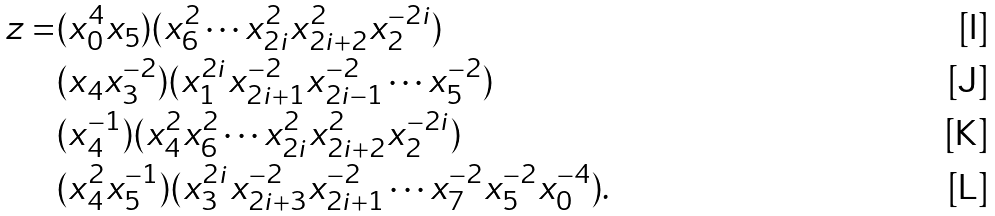<formula> <loc_0><loc_0><loc_500><loc_500>z = & ( x _ { 0 } ^ { 4 } x _ { 5 } ) ( x _ { 6 } ^ { 2 } \cdots x _ { 2 i } ^ { 2 } x _ { 2 i + 2 } ^ { 2 } x _ { 2 } ^ { - 2 i } ) \\ & ( x _ { 4 } x _ { 3 } ^ { - 2 } ) ( x _ { 1 } ^ { 2 i } x _ { 2 i + 1 } ^ { - 2 } x _ { 2 i - 1 } ^ { - 2 } \cdots x _ { 5 } ^ { - 2 } ) \\ & ( x _ { 4 } ^ { - 1 } ) ( x _ { 4 } ^ { 2 } x _ { 6 } ^ { 2 } \cdots x _ { 2 i } ^ { 2 } x _ { 2 i + 2 } ^ { 2 } x _ { 2 } ^ { - 2 i } ) \\ & ( x _ { 4 } ^ { 2 } x _ { 5 } ^ { - 1 } ) ( x _ { 3 } ^ { 2 i } x _ { 2 i + 3 } ^ { - 2 } x _ { 2 i + 1 } ^ { - 2 } \cdots x _ { 7 } ^ { - 2 } x _ { 5 } ^ { - 2 } x _ { 0 } ^ { - 4 } ) .</formula> 